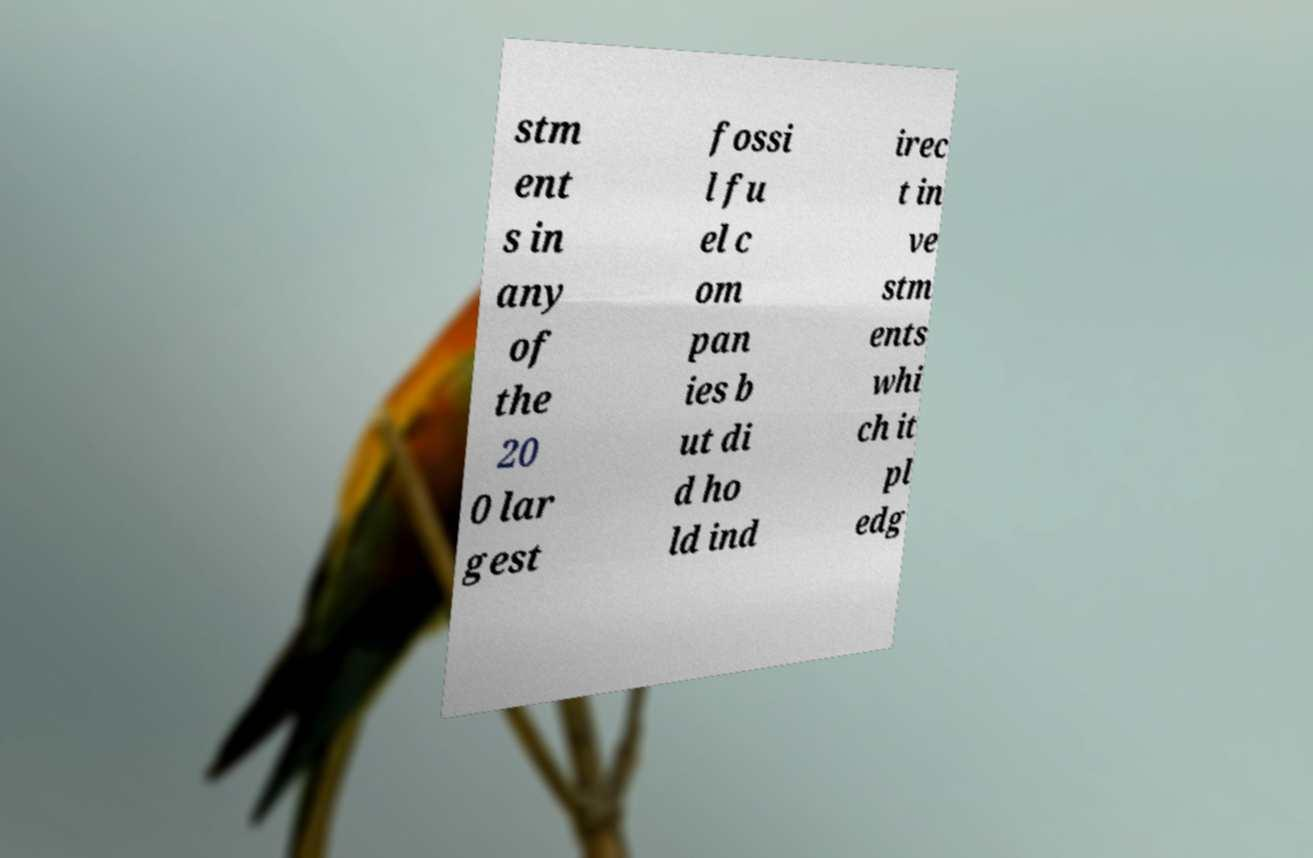For documentation purposes, I need the text within this image transcribed. Could you provide that? stm ent s in any of the 20 0 lar gest fossi l fu el c om pan ies b ut di d ho ld ind irec t in ve stm ents whi ch it pl edg 